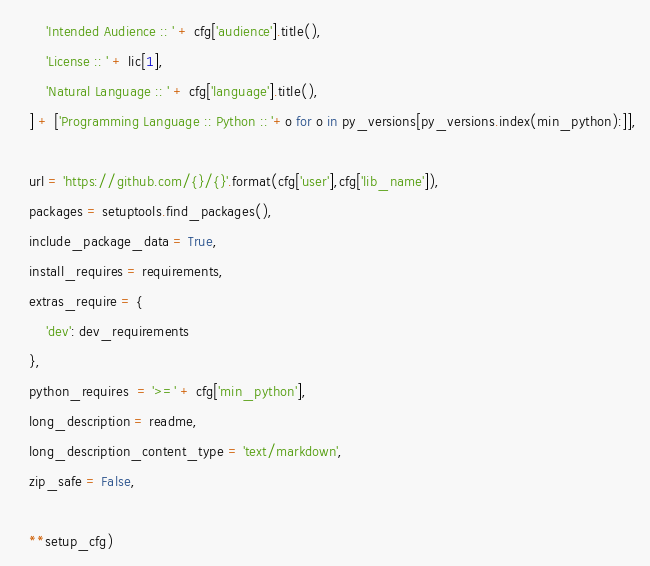<code> <loc_0><loc_0><loc_500><loc_500><_Python_>        'Intended Audience :: ' + cfg['audience'].title(),
        'License :: ' + lic[1],
        'Natural Language :: ' + cfg['language'].title(),
    ] + ['Programming Language :: Python :: '+o for o in py_versions[py_versions.index(min_python):]],

    url = 'https://github.com/{}/{}'.format(cfg['user'],cfg['lib_name']),
    packages = setuptools.find_packages(),
    include_package_data = True,
    install_requires = requirements,
    extras_require = {
        'dev': dev_requirements
    },
    python_requires  = '>=' + cfg['min_python'],
    long_description = readme,
    long_description_content_type = 'text/markdown',
    zip_safe = False,

    **setup_cfg)

</code> 